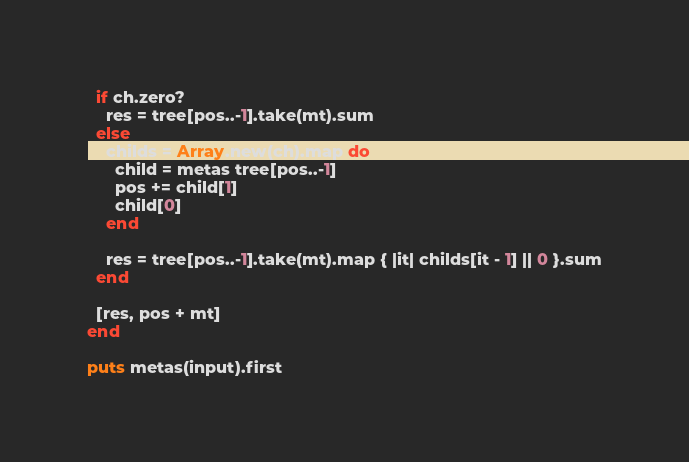<code> <loc_0><loc_0><loc_500><loc_500><_Ruby_>
  if ch.zero?
    res = tree[pos..-1].take(mt).sum
  else
    childs = Array.new(ch).map do
      child = metas tree[pos..-1]
      pos += child[1]
      child[0]
    end

    res = tree[pos..-1].take(mt).map { |it| childs[it - 1] || 0 }.sum
  end

  [res, pos + mt]
end

puts metas(input).first
</code> 